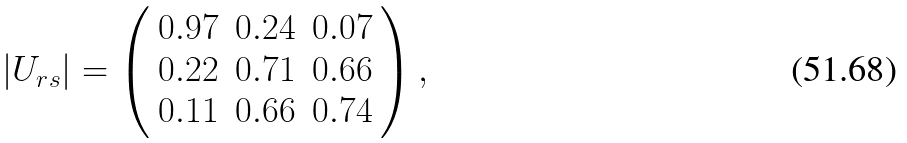Convert formula to latex. <formula><loc_0><loc_0><loc_500><loc_500>| U _ { r s } | = \left ( \begin{array} { c c c } 0 . 9 7 & 0 . 2 4 & 0 . 0 7 \\ 0 . 2 2 & 0 . 7 1 & 0 . 6 6 \\ 0 . 1 1 & 0 . 6 6 & 0 . 7 4 \end{array} \right ) ,</formula> 